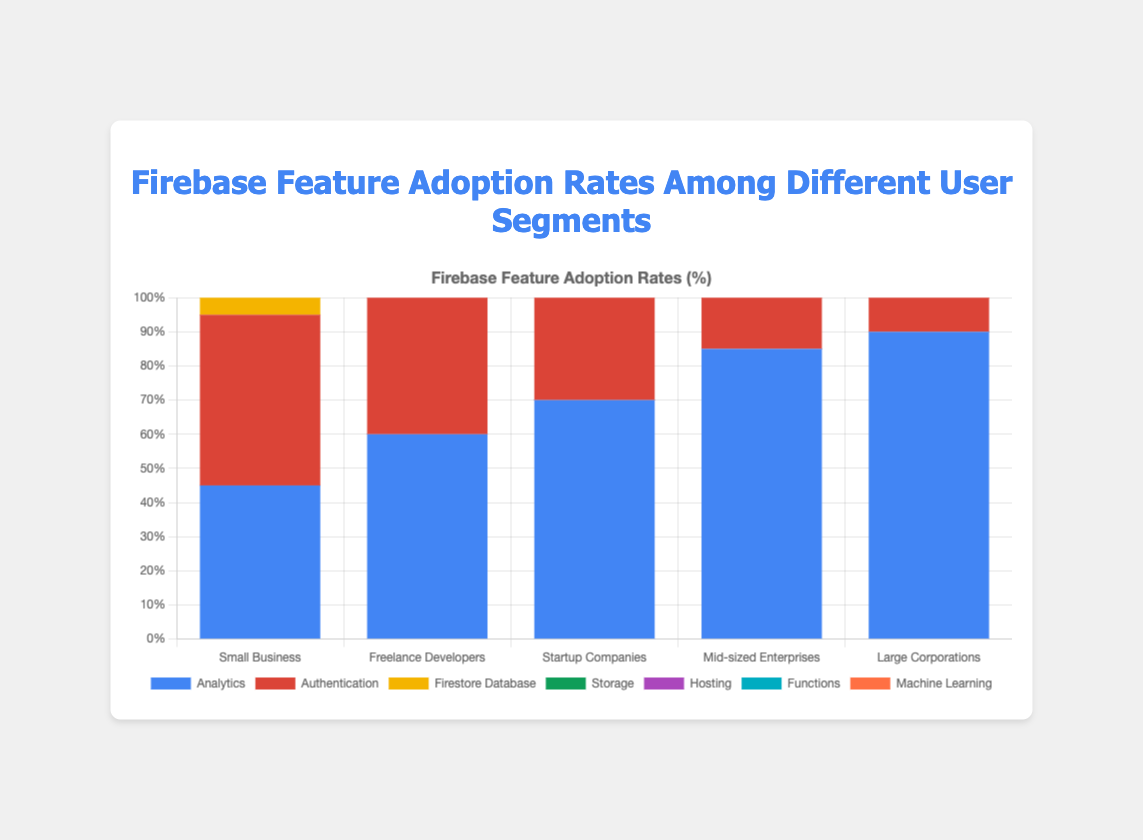What's the highest adoption rate for the 'Authentication' feature, and which user segment does it belong to? The 'Authentication' feature's highest adoption rate is observed with the 'Large Corporations' user segment, which has an 88% adoption rate. Validate by comparing this value with others in the 'Authentication' category across user segments.
Answer: 88%, Large Corporations Among all user segments, which one has the lowest adoption rate for 'Machine Learning'? The 'Machine Learning' adoption rate is lowest for the 'Small Business' user segment at 10%. This is confirmed by evaluating the 'Machine Learning' rates across all user segments.
Answer: Small Business Compare the adoption rates of 'Hosting' and 'Storage' features for the 'Mid-sized Enterprises.' Which one is higher and by how much? For 'Mid-sized Enterprises,' the 'Hosting' feature has a 65% adoption rate, while 'Storage' is at 70%. The difference is 70% - 65% = 5%, with 'Storage' higher by 5%.
Answer: Storage by 5% What is the total adoption rate for 'Freelance Developers' across all listed features? Summing up the adoption rates for 'Freelance Developers' across all features (60 + 70 + 50 + 45 + 50 + 35 + 20) results in a total of 330%.
Answer: 330% Which feature has the least varying adoption rates across all user segments, and what are the values? The 'Machine Learning' feature has the least varying adoption rates across segments (10%, 20%, 30%, 40%, 60%). This can be observed by the relatively smaller range of values compared to other features.
Answer: Machine Learning (10%, 20%, 30%, 40%, 60%) What's the average adoption rate for 'Analytics' across all user segments? Add up the 'Analytics' adoption rates (45 + 60 + 70 + 85 + 90) and divide by the number of segments (5). (45 + 60 + 70 + 85 + 90) / 5 = 350 / 5 = 70.
Answer: 70 Which user segment has the highest overall adoption rate across all features, and what is the rate? Sum the adoption rates for each user segment and compare. 'Large Corporations' has the highest total adoption rate (90 + 88 + 85 + 80 + 78 + 70 + 60 = 551%).
Answer: Large Corporations, 551% By how much does the 'Firestore Database' adoption rate for 'Startup Companies' exceed that for 'Small Business'? 'Startup Companies' have a 65% adoption rate for 'Firestore Database,' while 'Small Business' has 35%. The difference is 65% - 35% = 30%.
Answer: 30% Which feature has the second-highest adoption rate for 'Freelance Developers', and what is the percentage? For 'Freelance Developers,' 'Authentication' has the highest rate at 70%, followed by 'Analytics' at 60%.
Answer: Analytics, 60% Considering only 'Small Business' and 'Large Corporations,' which feature has the largest absolute difference in adoption rate between the two segments, and what is the difference? Calculate the absolute differences for each feature. 'Machine Learning' shows the largest difference: 60% (Large Corporations) - 10% (Small Business) = 50%.
Answer: Machine Learning, 50% 